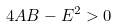Convert formula to latex. <formula><loc_0><loc_0><loc_500><loc_500>4 A B - E ^ { 2 } > 0</formula> 